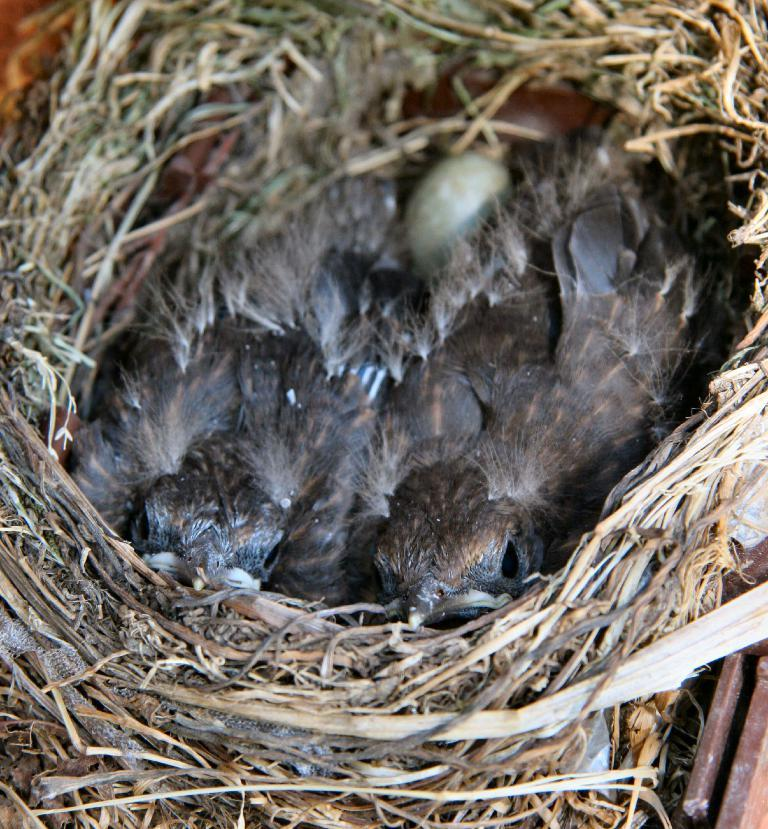What is located in the image? There is a nest in the image. What can be found inside the nest? There are baby birds or chicks in the nest. What type of building is visible in the image? There is no building present in the image; it features a nest with baby birds or chicks. What type of lip product is being used by the baby birds or chicks in the image? There is no lip product visible in the image, as it features a nest with baby birds or chicks. 